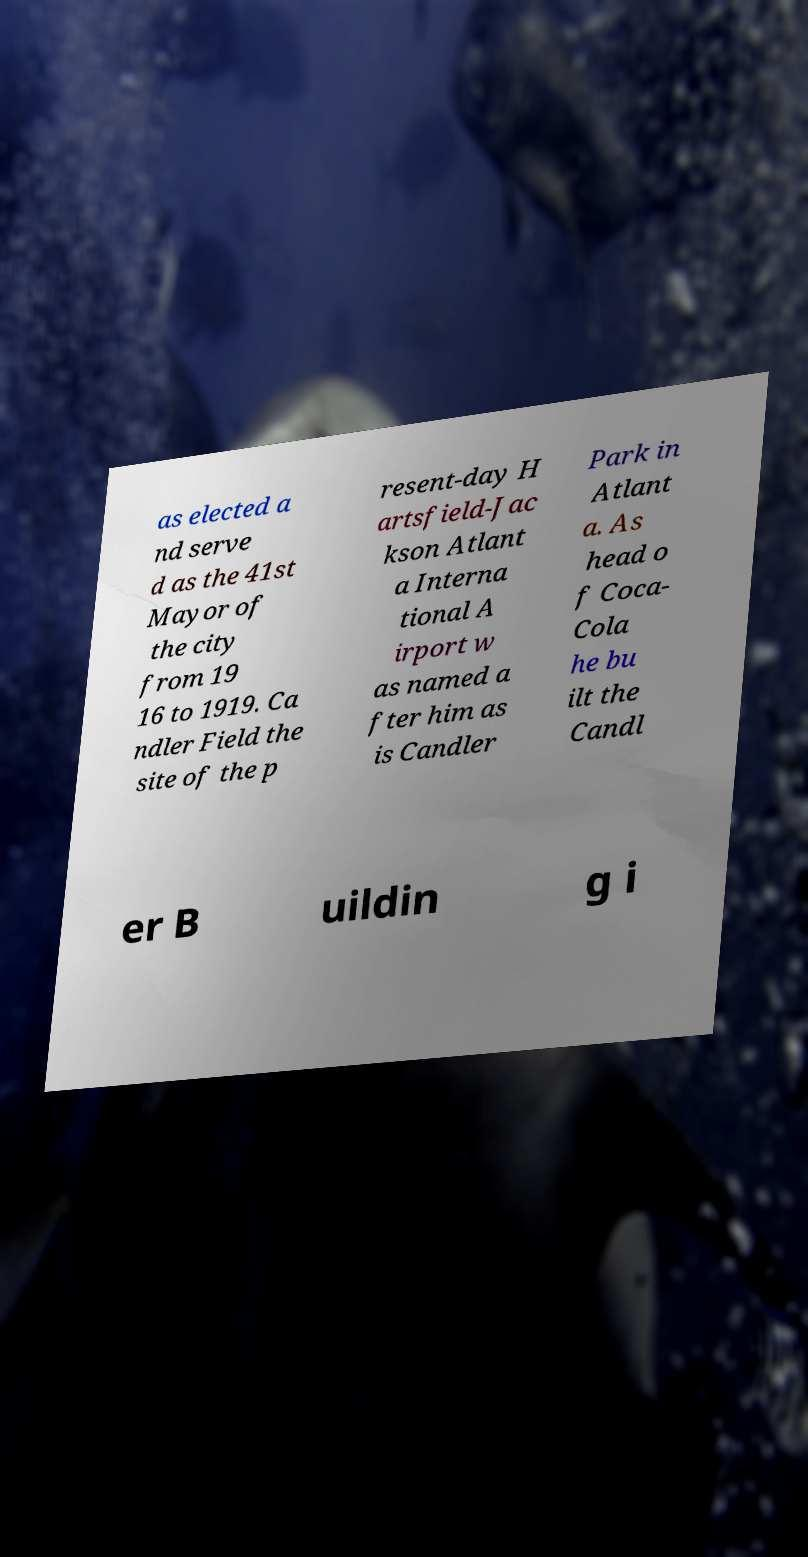Please read and relay the text visible in this image. What does it say? as elected a nd serve d as the 41st Mayor of the city from 19 16 to 1919. Ca ndler Field the site of the p resent-day H artsfield-Jac kson Atlant a Interna tional A irport w as named a fter him as is Candler Park in Atlant a. As head o f Coca- Cola he bu ilt the Candl er B uildin g i 